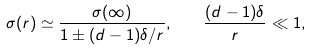Convert formula to latex. <formula><loc_0><loc_0><loc_500><loc_500>\sigma ( r ) \simeq \frac { \sigma ( \infty ) } { 1 \pm ( d - 1 ) \delta / r } , \quad \frac { ( d - 1 ) \delta } { r } \ll 1 ,</formula> 